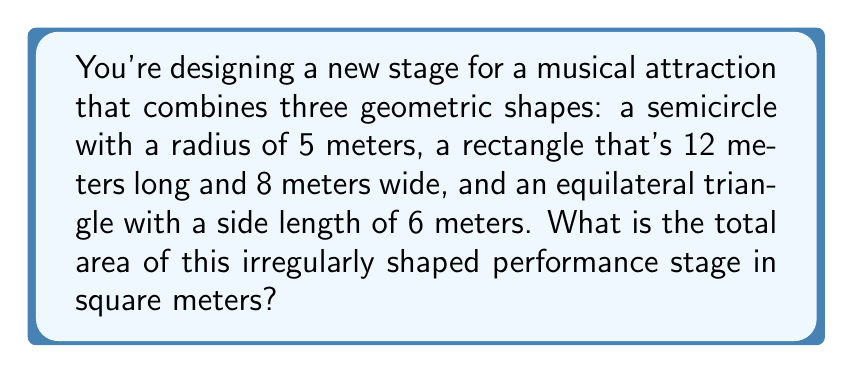Provide a solution to this math problem. Let's calculate the area of each shape separately and then sum them up:

1. Semicircle area:
   The area of a full circle is $A = \pi r^2$, so for a semicircle, it's half of that.
   $$A_{semicircle} = \frac{1}{2} \pi r^2 = \frac{1}{2} \pi (5^2) = \frac{25\pi}{2} \approx 39.27 \text{ m}^2$$

2. Rectangle area:
   $$A_{rectangle} = length \times width = 12 \times 8 = 96 \text{ m}^2$$

3. Equilateral triangle area:
   For an equilateral triangle with side length $s$, the area is:
   $$A_{triangle} = \frac{\sqrt{3}}{4}s^2$$
   With $s = 6$:
   $$A_{triangle} = \frac{\sqrt{3}}{4}(6^2) = 9\sqrt{3} \approx 15.59 \text{ m}^2$$

Total area:
$$A_{total} = A_{semicircle} + A_{rectangle} + A_{triangle}$$
$$A_{total} = \frac{25\pi}{2} + 96 + 9\sqrt{3} \approx 39.27 + 96 + 15.59 = 150.86 \text{ m}^2$$
Answer: $150.86 \text{ m}^2$ 